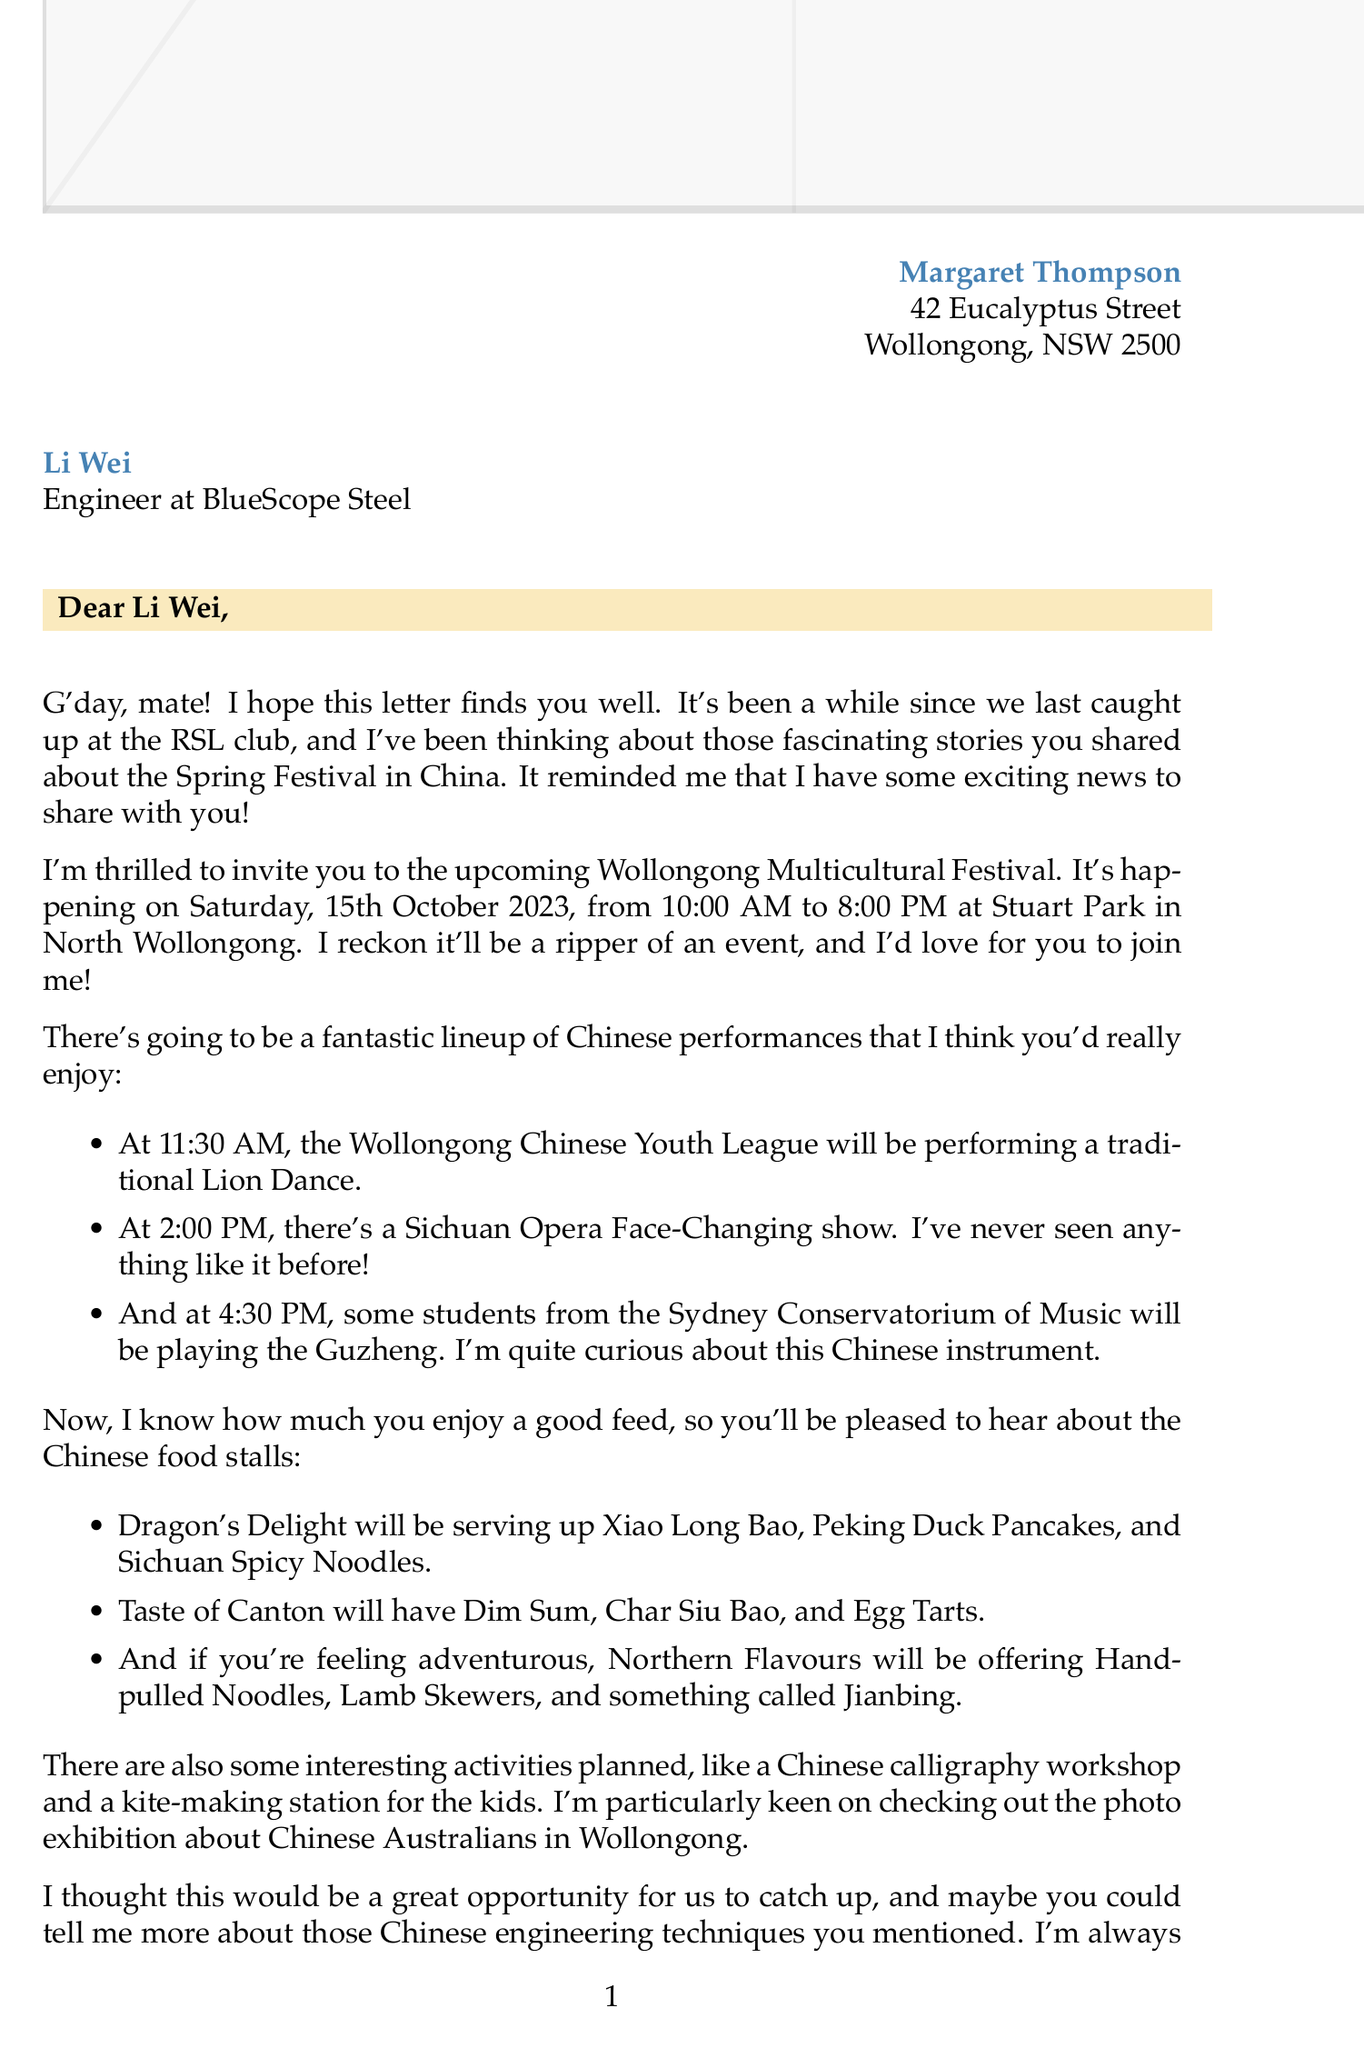What is the date of the Wollongong Multicultural Festival? The date is clearly stated in the festival details section of the document.
Answer: Saturday, 15th October 2023 What time does the Lion Dance performance start? The specific time for the Lion Dance is mentioned in the list of Chinese performances.
Answer: 11:30 AM Who is the sender of the letter? The sender's name is provided at the beginning of the letter.
Answer: Margaret Thompson What are some specialties at the "Dragon's Delight" stall? The specialties are listed under the Chinese cuisine section related to the food stalls.
Answer: Xiao Long Bao, Peking Duck Pancakes, Sichuan Spicy Noodles What transportation options are mentioned for getting to the festival? The transportation options are detailed in the transportation section of the document.
Answer: Free shuttle bus service, parking How does Margaret feel about the festival? The tone and wording of the letter express Margaret's excitement about the upcoming event.
Answer: Thrilled What activity is offered for children at the festival? The children's activity is described in the additional activities section.
Answer: Kite-making station What does Margaret want to learn more about during the festival? Margaret expresses her curiosity about a specific topic towards the end of the letter.
Answer: Chinese engineering techniques What does the letter remind Margaret of? The letter includes a personal touch that links the festival to past conversations.
Answer: Li Wei's stories about Spring Festival in China 